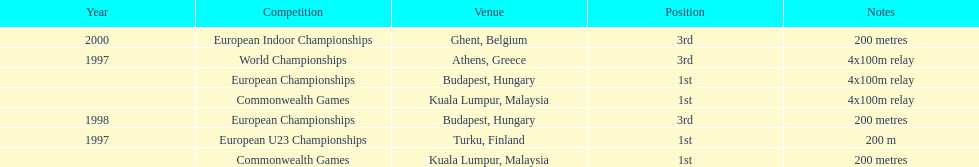How many 4x 100m relays were run? 3. 